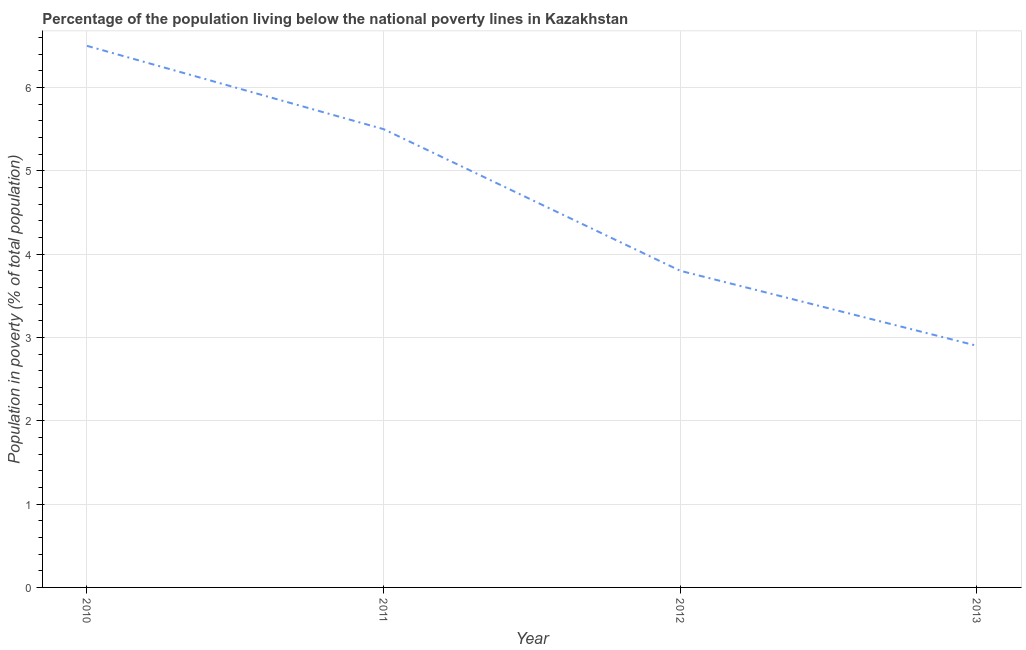Across all years, what is the maximum percentage of population living below poverty line?
Your answer should be very brief. 6.5. Across all years, what is the minimum percentage of population living below poverty line?
Ensure brevity in your answer.  2.9. In which year was the percentage of population living below poverty line minimum?
Your answer should be very brief. 2013. What is the average percentage of population living below poverty line per year?
Offer a very short reply. 4.67. What is the median percentage of population living below poverty line?
Keep it short and to the point. 4.65. Do a majority of the years between 2010 and 2011 (inclusive) have percentage of population living below poverty line greater than 2.6 %?
Offer a very short reply. Yes. What is the ratio of the percentage of population living below poverty line in 2012 to that in 2013?
Offer a terse response. 1.31. Is the percentage of population living below poverty line in 2010 less than that in 2011?
Your response must be concise. No. Is the difference between the percentage of population living below poverty line in 2010 and 2011 greater than the difference between any two years?
Offer a terse response. No. What is the difference between the highest and the second highest percentage of population living below poverty line?
Offer a very short reply. 1. In how many years, is the percentage of population living below poverty line greater than the average percentage of population living below poverty line taken over all years?
Provide a short and direct response. 2. Does the percentage of population living below poverty line monotonically increase over the years?
Your answer should be very brief. No. How many lines are there?
Offer a terse response. 1. How many years are there in the graph?
Keep it short and to the point. 4. What is the title of the graph?
Your answer should be very brief. Percentage of the population living below the national poverty lines in Kazakhstan. What is the label or title of the X-axis?
Your answer should be very brief. Year. What is the label or title of the Y-axis?
Provide a short and direct response. Population in poverty (% of total population). What is the Population in poverty (% of total population) of 2012?
Provide a short and direct response. 3.8. What is the Population in poverty (% of total population) of 2013?
Your response must be concise. 2.9. What is the difference between the Population in poverty (% of total population) in 2010 and 2013?
Your answer should be very brief. 3.6. What is the difference between the Population in poverty (% of total population) in 2011 and 2013?
Your response must be concise. 2.6. What is the ratio of the Population in poverty (% of total population) in 2010 to that in 2011?
Provide a short and direct response. 1.18. What is the ratio of the Population in poverty (% of total population) in 2010 to that in 2012?
Provide a succinct answer. 1.71. What is the ratio of the Population in poverty (% of total population) in 2010 to that in 2013?
Provide a succinct answer. 2.24. What is the ratio of the Population in poverty (% of total population) in 2011 to that in 2012?
Provide a short and direct response. 1.45. What is the ratio of the Population in poverty (% of total population) in 2011 to that in 2013?
Your answer should be compact. 1.9. What is the ratio of the Population in poverty (% of total population) in 2012 to that in 2013?
Your answer should be compact. 1.31. 